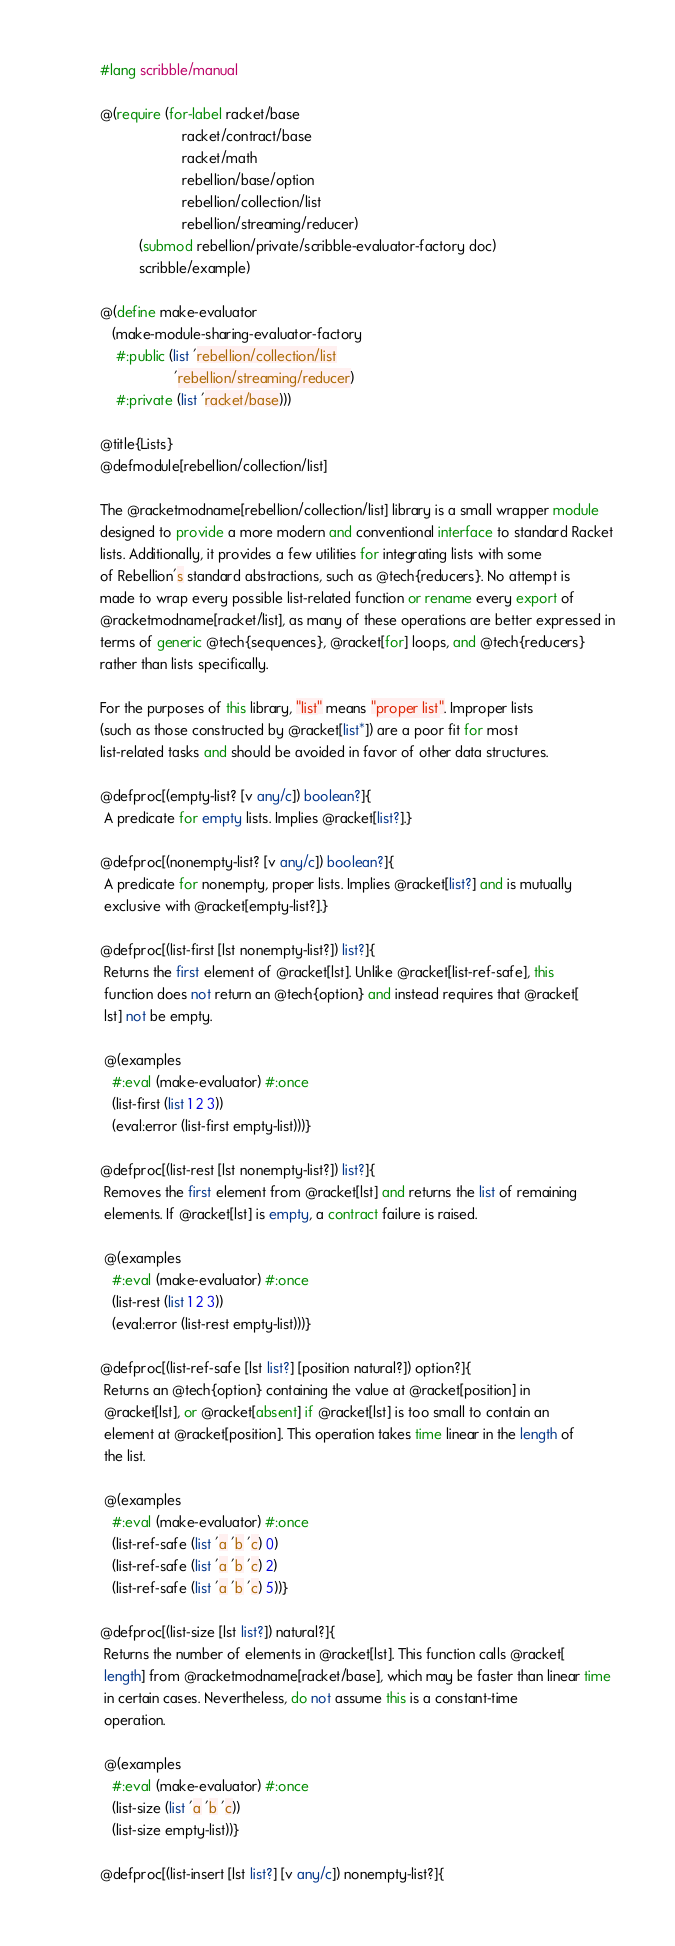<code> <loc_0><loc_0><loc_500><loc_500><_Racket_>#lang scribble/manual

@(require (for-label racket/base
                     racket/contract/base
                     racket/math
                     rebellion/base/option
                     rebellion/collection/list
                     rebellion/streaming/reducer)
          (submod rebellion/private/scribble-evaluator-factory doc)
          scribble/example)

@(define make-evaluator
   (make-module-sharing-evaluator-factory
    #:public (list 'rebellion/collection/list
                   'rebellion/streaming/reducer)
    #:private (list 'racket/base)))

@title{Lists}
@defmodule[rebellion/collection/list]

The @racketmodname[rebellion/collection/list] library is a small wrapper module
designed to provide a more modern and conventional interface to standard Racket
lists. Additionally, it provides a few utilities for integrating lists with some
of Rebellion's standard abstractions, such as @tech{reducers}. No attempt is
made to wrap every possible list-related function or rename every export of
@racketmodname[racket/list], as many of these operations are better expressed in
terms of generic @tech{sequences}, @racket[for] loops, and @tech{reducers}
rather than lists specifically.

For the purposes of this library, "list" means "proper list". Improper lists
(such as those constructed by @racket[list*]) are a poor fit for most
list-related tasks and should be avoided in favor of other data structures.

@defproc[(empty-list? [v any/c]) boolean?]{
 A predicate for empty lists. Implies @racket[list?].}

@defproc[(nonempty-list? [v any/c]) boolean?]{
 A predicate for nonempty, proper lists. Implies @racket[list?] and is mutually
 exclusive with @racket[empty-list?].}

@defproc[(list-first [lst nonempty-list?]) list?]{
 Returns the first element of @racket[lst]. Unlike @racket[list-ref-safe], this
 function does not return an @tech{option} and instead requires that @racket[
 lst] not be empty.

 @(examples
   #:eval (make-evaluator) #:once
   (list-first (list 1 2 3))
   (eval:error (list-first empty-list)))}

@defproc[(list-rest [lst nonempty-list?]) list?]{
 Removes the first element from @racket[lst] and returns the list of remaining
 elements. If @racket[lst] is empty, a contract failure is raised.

 @(examples
   #:eval (make-evaluator) #:once
   (list-rest (list 1 2 3))
   (eval:error (list-rest empty-list)))}

@defproc[(list-ref-safe [lst list?] [position natural?]) option?]{
 Returns an @tech{option} containing the value at @racket[position] in
 @racket[lst], or @racket[absent] if @racket[lst] is too small to contain an
 element at @racket[position]. This operation takes time linear in the length of
 the list.

 @(examples
   #:eval (make-evaluator) #:once
   (list-ref-safe (list 'a 'b 'c) 0)
   (list-ref-safe (list 'a 'b 'c) 2)
   (list-ref-safe (list 'a 'b 'c) 5))}

@defproc[(list-size [lst list?]) natural?]{
 Returns the number of elements in @racket[lst]. This function calls @racket[
 length] from @racketmodname[racket/base], which may be faster than linear time
 in certain cases. Nevertheless, do not assume this is a constant-time
 operation.

 @(examples
   #:eval (make-evaluator) #:once
   (list-size (list 'a 'b 'c))
   (list-size empty-list))}

@defproc[(list-insert [lst list?] [v any/c]) nonempty-list?]{</code> 